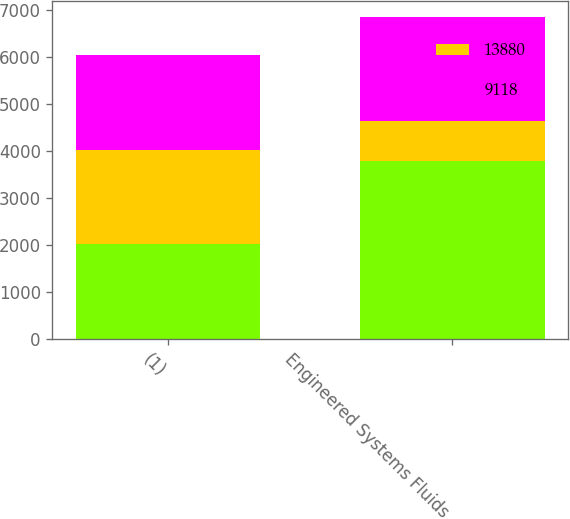Convert chart to OTSL. <chart><loc_0><loc_0><loc_500><loc_500><stacked_bar_chart><ecel><fcel>(1)<fcel>Engineered Systems Fluids<nl><fcel>nan<fcel>2014<fcel>3784<nl><fcel>13880<fcel>2013<fcel>850<nl><fcel>9118<fcel>2012<fcel>2215<nl></chart> 